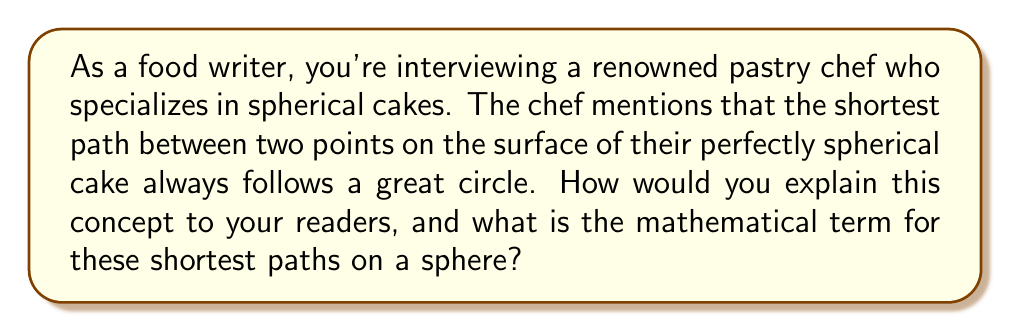Provide a solution to this math problem. To explain this concept to readers, we can break it down into steps:

1. Understand what a geodesic is:
   A geodesic is the shortest path between two points on a curved surface.

2. Visualize a spherical cake:
   Imagine a perfectly round cake, like a globe.

3. Great circles on a sphere:
   A great circle is the largest circle that can be drawn on a sphere's surface, where the plane of the circle passes through the center of the sphere.

4. Properties of great circles:
   - They divide the sphere into two equal hemispheres.
   - They represent the shortest distance between two points on a sphere.

5. Mathematical representation:
   On a sphere with radius $R$, the equation of a great circle in spherical coordinates $(\theta, \phi)$ is:

   $$\tan(\phi) = A \cos(\theta) + B \sin(\theta)$$

   where $A$ and $B$ are constants determined by the two points the great circle passes through.

6. Why great circles are geodesics:
   - They follow the curvature of the sphere.
   - Any deviation from a great circle path would result in a longer distance.

7. Examples in real life:
   - Airplane routes often follow great circle paths for efficiency.
   - On Earth, the equator is a great circle.

The mathematical term for these shortest paths (great circles) on a sphere is "geodesics."
Answer: Geodesics 